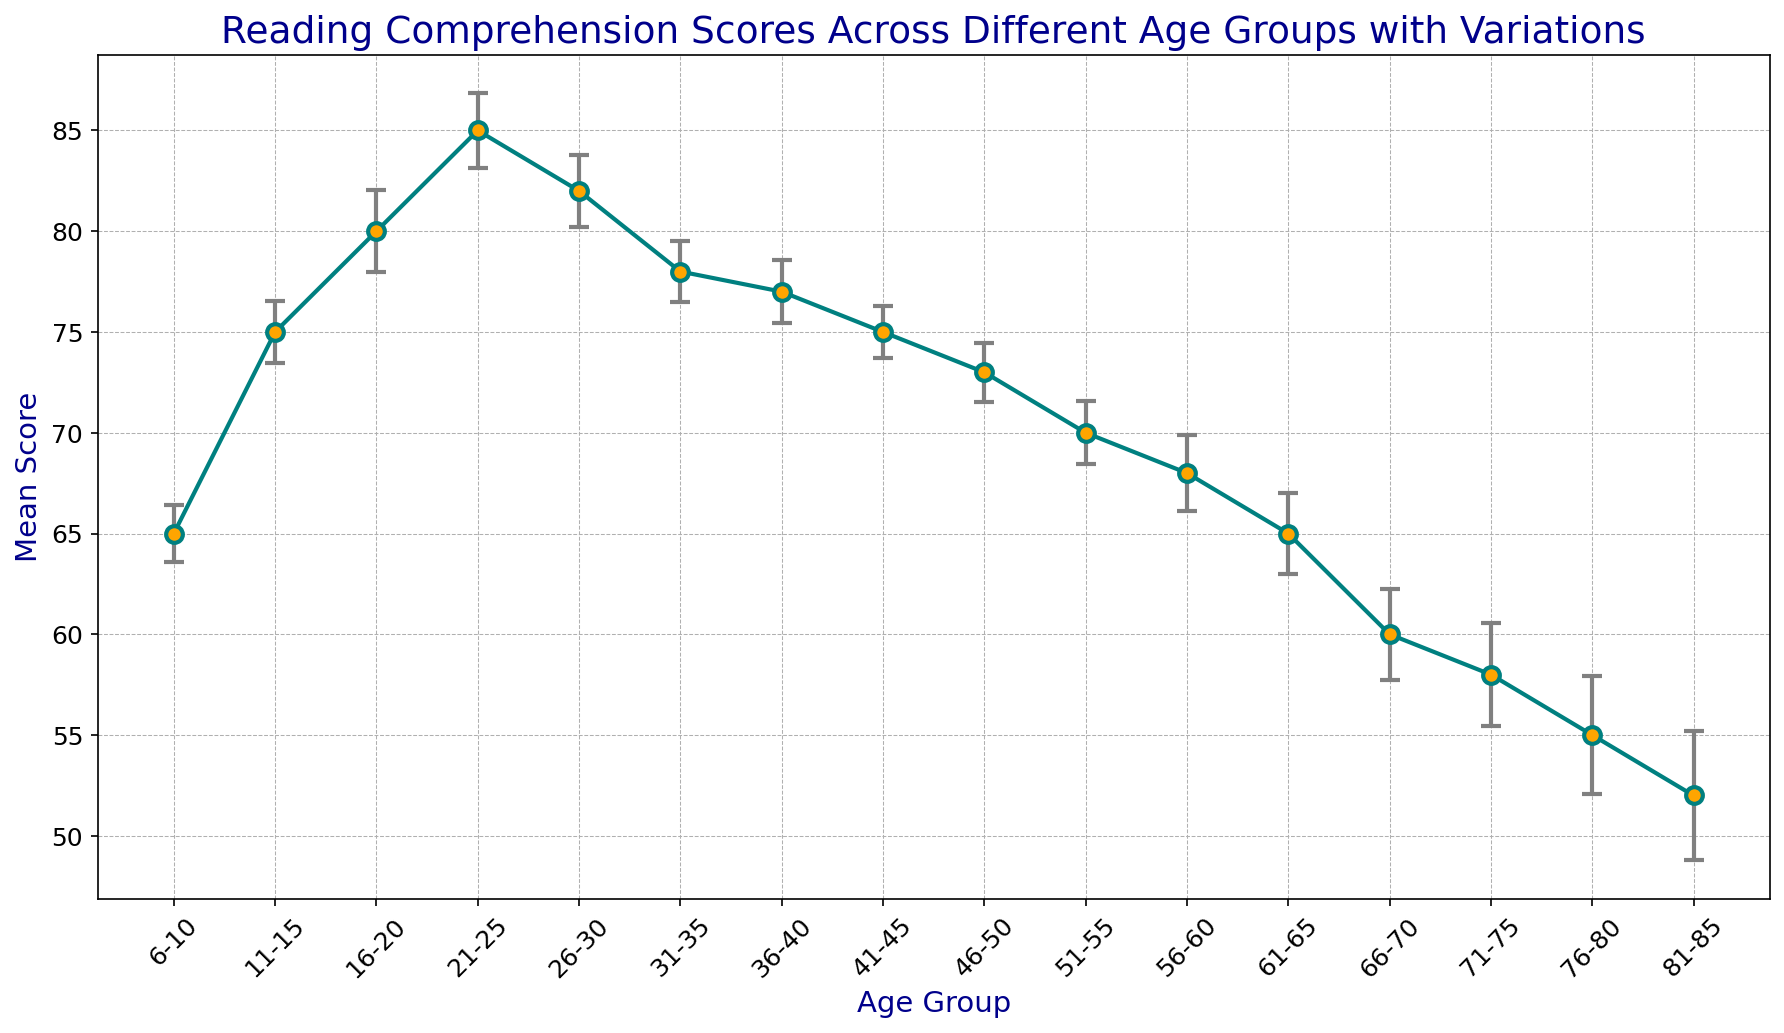What's the age group with the highest mean score? The highest point on the plot corresponds to the age group with the highest mean score. According to the figure, the age group 21-25 has the highest mean score.
Answer: 21-25 Which age group has the lowest mean score? The lowest point on the plot indicates the age group with the lowest mean score. From the figure, the age group 81-85 has the lowest mean score.
Answer: 81-85 By how many points does the mean score of age group 11-15 exceed that of age group 6-10? Subtract the mean score of age group 6-10 from that of age group 11-15. The mean score for age group 11-15 is 75, and for 6-10, it's 65. The difference is 75 - 65 = 10 points.
Answer: 10 points Which age group has the largest error bar (standard error)? The largest vertical line (error bar) on the plot corresponds to the age group with the largest standard error. The figure shows that the age group 81-85 has the highest error bar.
Answer: 81-85 What is the mean score for the 36-40 age group, and how does it compare to the mean score of the 41-45 age group? The mean scores are shown as points on the plot. The age group 36-40 has a mean score of 77, while the age group 41-45 has a mean score of 75. So, the 36-40 age group has a mean score that is 2 points higher than that of the 41-45 age group.
Answer: 77 and 2 points higher Calculate the average of the mean scores of the age groups 56-60 and 61-65. Add the mean scores of the age groups and then divide by 2. The mean score for 56-60 is 68, and for 61-65 is 65. (68 + 65) / 2 = 66.5.
Answer: 66.5 Which age group shows a decline in mean score compared to the previous age group, starting from age group 26-30 up to 81-85? By visually inspecting the plot for descending points after the age group 26-30, we can see the mean score declines progressively until age group 81-85. Each subsequent age group (31-35 through 81-85) has a lower score than the previous group.
Answer: 31-35 through 81-85 What is the range of mean scores in the plot? The range is calculated from the maximum mean score to the minimum mean score. The highest mean score is 85 (age group 21-25), and the lowest is 52 (age group 81-85). The range is 85 - 52 = 33.
Answer: 33 What is the difference in mean score between the age groups 66-70 and 71-75, and how does this compare to the difference between the age groups 71-75 and 76-80? Subtract the mean score of 71-75 from 66-70 and 76-80 from 71-75. The difference between 66-70 and 71-75 is 60 - 58 = 2 points. The difference between 71-75 and 76-80 is 58 - 55 = 3 points.
Answer: 2 points and 3 points 